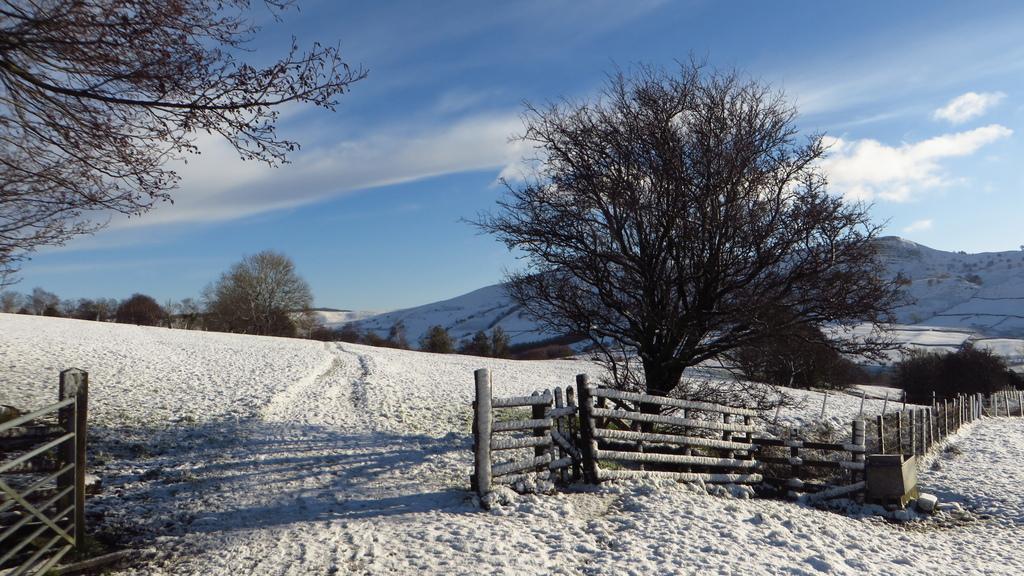Describe this image in one or two sentences. In this picture at the top we can see the blue sky and at the bottom the whole area is covered with ice. We have trees everywhere and here some part of the area is covered with wooden fencing. 